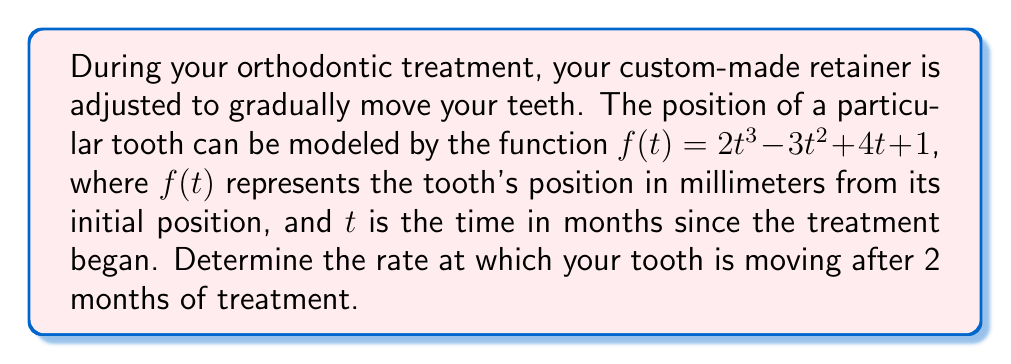Show me your answer to this math problem. To solve this problem, we need to find the rate of change of the tooth's position at $t = 2$ months. This can be done by calculating the derivative of the given function and evaluating it at $t = 2$.

Step 1: Find the derivative of $f(t)$.
The function is $f(t) = 2t^3 - 3t^2 + 4t + 1$
Using the power rule and the constant rule, we get:
$$f'(t) = 6t^2 - 6t + 4$$

Step 2: Evaluate $f'(t)$ at $t = 2$.
$$f'(2) = 6(2)^2 - 6(2) + 4$$
$$f'(2) = 6(4) - 12 + 4$$
$$f'(2) = 24 - 12 + 4$$
$$f'(2) = 16$$

The rate of change is measured in millimeters per month, as the original function measures position in millimeters and time in months.
Answer: The rate at which the tooth is moving after 2 months of treatment is 16 mm/month. 